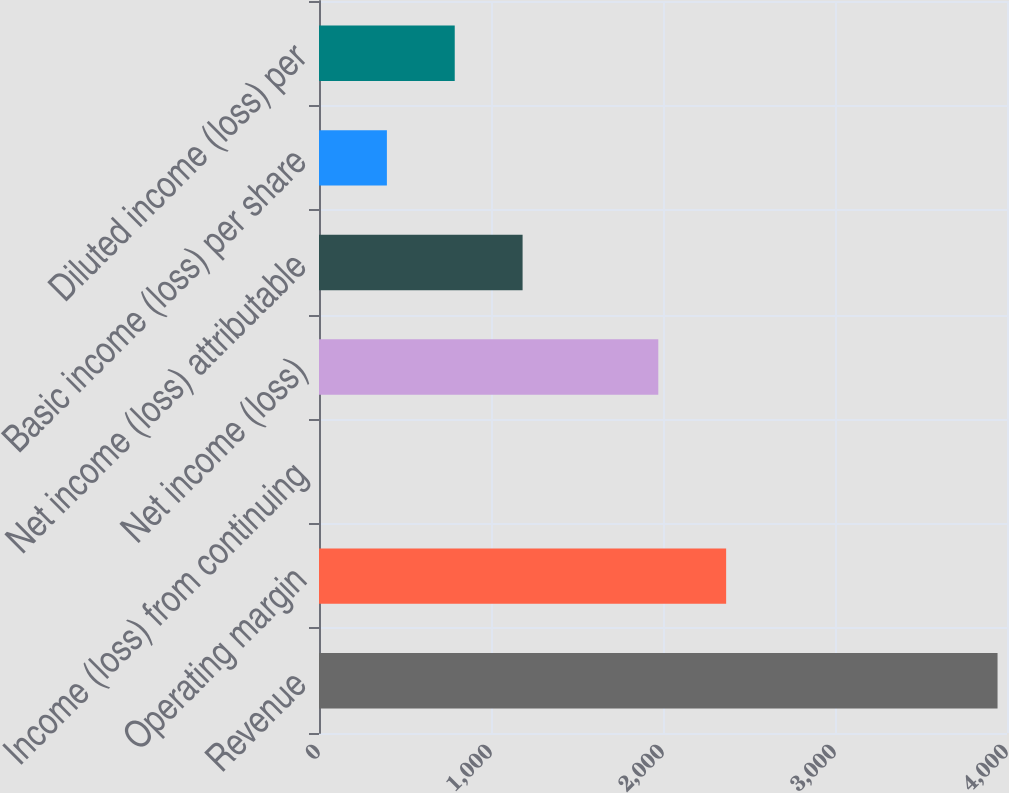Convert chart. <chart><loc_0><loc_0><loc_500><loc_500><bar_chart><fcel>Revenue<fcel>Operating margin<fcel>Income (loss) from continuing<fcel>Net income (loss)<fcel>Net income (loss) attributable<fcel>Basic income (loss) per share<fcel>Diluted income (loss) per<nl><fcel>3945<fcel>2367.1<fcel>0.22<fcel>1972.62<fcel>1183.66<fcel>394.7<fcel>789.18<nl></chart> 